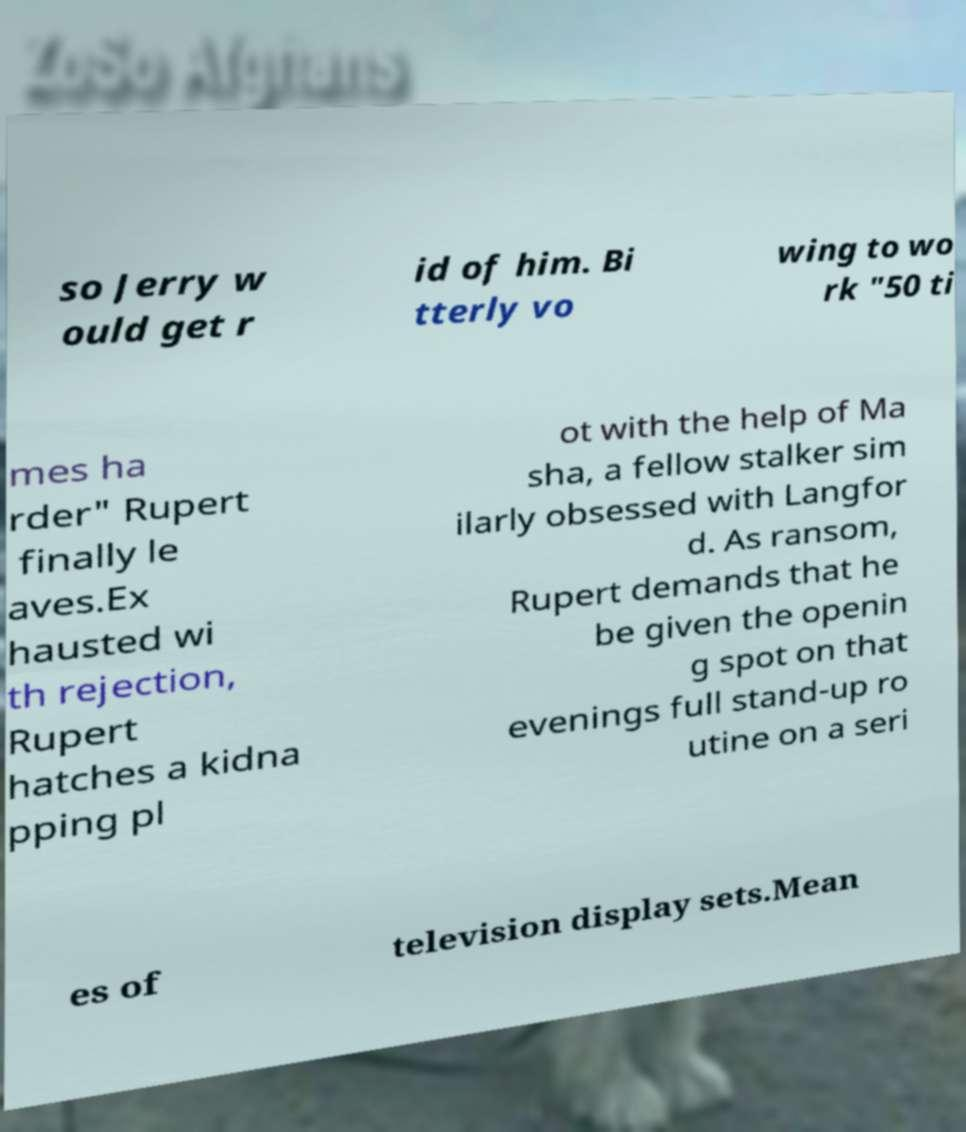Please identify and transcribe the text found in this image. so Jerry w ould get r id of him. Bi tterly vo wing to wo rk "50 ti mes ha rder" Rupert finally le aves.Ex hausted wi th rejection, Rupert hatches a kidna pping pl ot with the help of Ma sha, a fellow stalker sim ilarly obsessed with Langfor d. As ransom, Rupert demands that he be given the openin g spot on that evenings full stand-up ro utine on a seri es of television display sets.Mean 